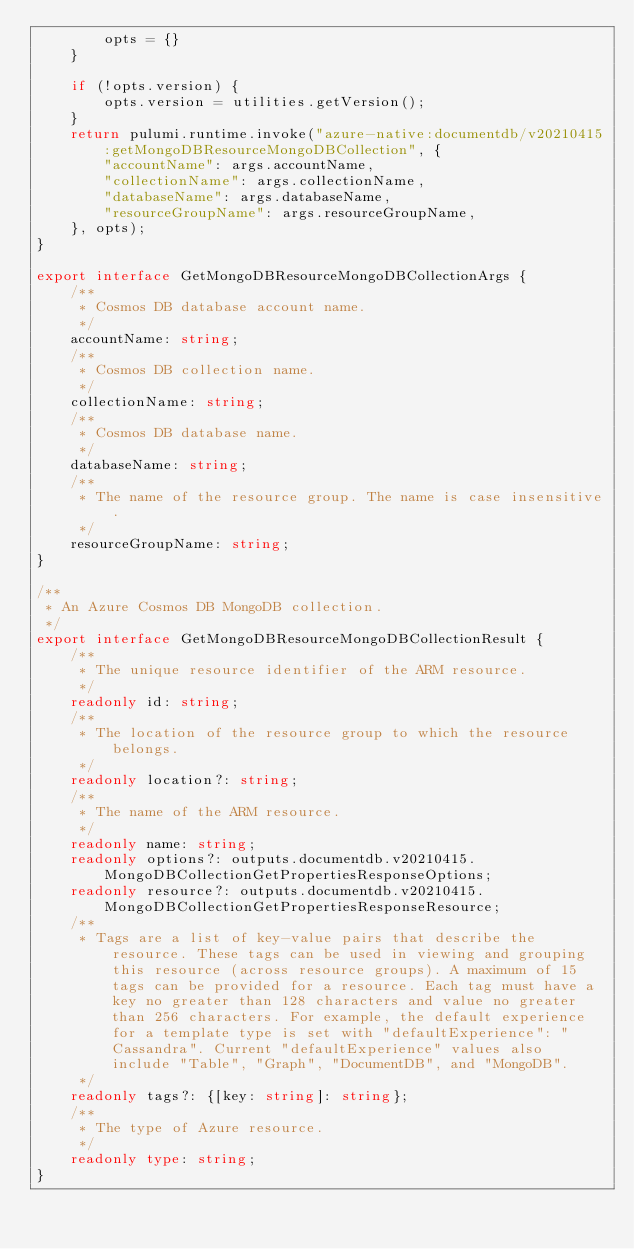Convert code to text. <code><loc_0><loc_0><loc_500><loc_500><_TypeScript_>        opts = {}
    }

    if (!opts.version) {
        opts.version = utilities.getVersion();
    }
    return pulumi.runtime.invoke("azure-native:documentdb/v20210415:getMongoDBResourceMongoDBCollection", {
        "accountName": args.accountName,
        "collectionName": args.collectionName,
        "databaseName": args.databaseName,
        "resourceGroupName": args.resourceGroupName,
    }, opts);
}

export interface GetMongoDBResourceMongoDBCollectionArgs {
    /**
     * Cosmos DB database account name.
     */
    accountName: string;
    /**
     * Cosmos DB collection name.
     */
    collectionName: string;
    /**
     * Cosmos DB database name.
     */
    databaseName: string;
    /**
     * The name of the resource group. The name is case insensitive.
     */
    resourceGroupName: string;
}

/**
 * An Azure Cosmos DB MongoDB collection.
 */
export interface GetMongoDBResourceMongoDBCollectionResult {
    /**
     * The unique resource identifier of the ARM resource.
     */
    readonly id: string;
    /**
     * The location of the resource group to which the resource belongs.
     */
    readonly location?: string;
    /**
     * The name of the ARM resource.
     */
    readonly name: string;
    readonly options?: outputs.documentdb.v20210415.MongoDBCollectionGetPropertiesResponseOptions;
    readonly resource?: outputs.documentdb.v20210415.MongoDBCollectionGetPropertiesResponseResource;
    /**
     * Tags are a list of key-value pairs that describe the resource. These tags can be used in viewing and grouping this resource (across resource groups). A maximum of 15 tags can be provided for a resource. Each tag must have a key no greater than 128 characters and value no greater than 256 characters. For example, the default experience for a template type is set with "defaultExperience": "Cassandra". Current "defaultExperience" values also include "Table", "Graph", "DocumentDB", and "MongoDB".
     */
    readonly tags?: {[key: string]: string};
    /**
     * The type of Azure resource.
     */
    readonly type: string;
}
</code> 